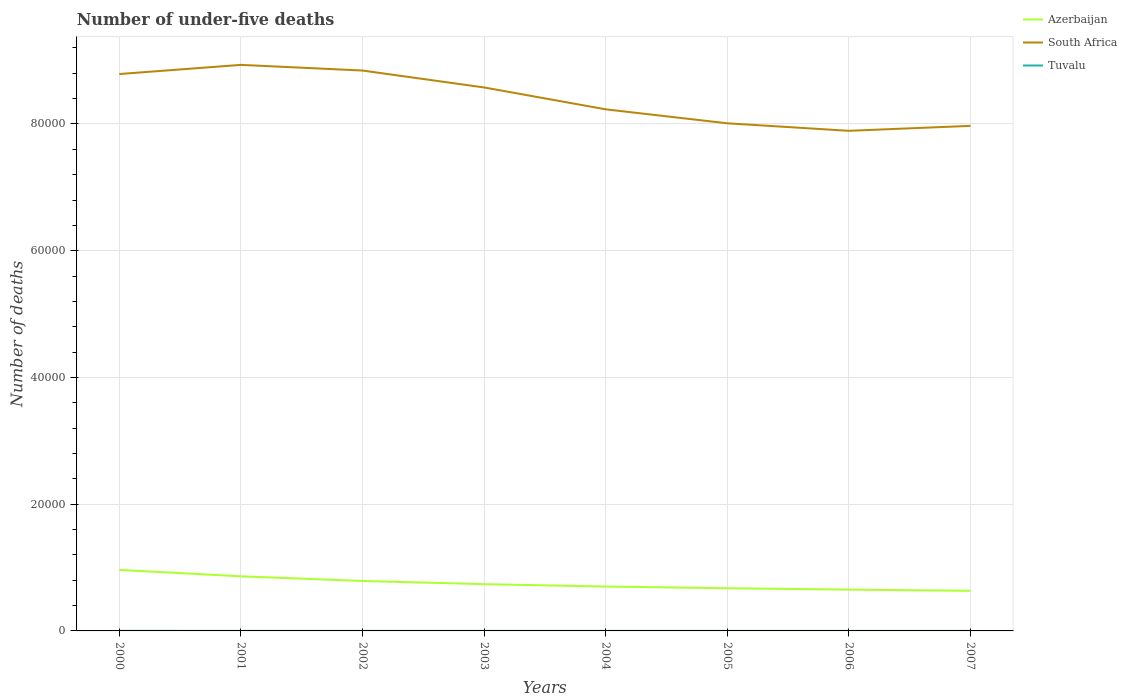How many different coloured lines are there?
Make the answer very short. 3. Across all years, what is the maximum number of under-five deaths in Azerbaijan?
Provide a short and direct response. 6329. What is the total number of under-five deaths in Azerbaijan in the graph?
Ensure brevity in your answer.  1239. What is the difference between the highest and the second highest number of under-five deaths in Azerbaijan?
Your response must be concise. 3301. How many lines are there?
Offer a very short reply. 3. What is the difference between two consecutive major ticks on the Y-axis?
Offer a very short reply. 2.00e+04. Does the graph contain any zero values?
Your response must be concise. No. Does the graph contain grids?
Your answer should be compact. Yes. Where does the legend appear in the graph?
Your answer should be very brief. Top right. How are the legend labels stacked?
Your answer should be very brief. Vertical. What is the title of the graph?
Offer a very short reply. Number of under-five deaths. Does "American Samoa" appear as one of the legend labels in the graph?
Your answer should be very brief. No. What is the label or title of the X-axis?
Provide a succinct answer. Years. What is the label or title of the Y-axis?
Provide a short and direct response. Number of deaths. What is the Number of deaths of Azerbaijan in 2000?
Your response must be concise. 9630. What is the Number of deaths of South Africa in 2000?
Offer a very short reply. 8.79e+04. What is the Number of deaths of Azerbaijan in 2001?
Give a very brief answer. 8618. What is the Number of deaths in South Africa in 2001?
Your answer should be compact. 8.93e+04. What is the Number of deaths in Azerbaijan in 2002?
Make the answer very short. 7883. What is the Number of deaths in South Africa in 2002?
Make the answer very short. 8.84e+04. What is the Number of deaths of Tuvalu in 2002?
Offer a very short reply. 11. What is the Number of deaths in Azerbaijan in 2003?
Ensure brevity in your answer.  7379. What is the Number of deaths of South Africa in 2003?
Ensure brevity in your answer.  8.58e+04. What is the Number of deaths of Tuvalu in 2003?
Provide a succinct answer. 10. What is the Number of deaths in Azerbaijan in 2004?
Your answer should be very brief. 7006. What is the Number of deaths in South Africa in 2004?
Ensure brevity in your answer.  8.23e+04. What is the Number of deaths of Tuvalu in 2004?
Your answer should be very brief. 9. What is the Number of deaths of Azerbaijan in 2005?
Ensure brevity in your answer.  6737. What is the Number of deaths in South Africa in 2005?
Your answer should be compact. 8.01e+04. What is the Number of deaths of Tuvalu in 2005?
Ensure brevity in your answer.  8. What is the Number of deaths in Azerbaijan in 2006?
Offer a terse response. 6519. What is the Number of deaths in South Africa in 2006?
Provide a short and direct response. 7.89e+04. What is the Number of deaths in Tuvalu in 2006?
Ensure brevity in your answer.  8. What is the Number of deaths in Azerbaijan in 2007?
Your answer should be very brief. 6329. What is the Number of deaths of South Africa in 2007?
Provide a succinct answer. 7.97e+04. Across all years, what is the maximum Number of deaths of Azerbaijan?
Provide a short and direct response. 9630. Across all years, what is the maximum Number of deaths in South Africa?
Your response must be concise. 8.93e+04. Across all years, what is the minimum Number of deaths in Azerbaijan?
Provide a succinct answer. 6329. Across all years, what is the minimum Number of deaths of South Africa?
Provide a short and direct response. 7.89e+04. Across all years, what is the minimum Number of deaths of Tuvalu?
Offer a very short reply. 7. What is the total Number of deaths of Azerbaijan in the graph?
Your response must be concise. 6.01e+04. What is the total Number of deaths of South Africa in the graph?
Make the answer very short. 6.72e+05. What is the difference between the Number of deaths in Azerbaijan in 2000 and that in 2001?
Your answer should be compact. 1012. What is the difference between the Number of deaths of South Africa in 2000 and that in 2001?
Provide a short and direct response. -1445. What is the difference between the Number of deaths of Azerbaijan in 2000 and that in 2002?
Provide a succinct answer. 1747. What is the difference between the Number of deaths in South Africa in 2000 and that in 2002?
Your answer should be very brief. -552. What is the difference between the Number of deaths in Tuvalu in 2000 and that in 2002?
Provide a short and direct response. 1. What is the difference between the Number of deaths in Azerbaijan in 2000 and that in 2003?
Offer a terse response. 2251. What is the difference between the Number of deaths of South Africa in 2000 and that in 2003?
Provide a succinct answer. 2119. What is the difference between the Number of deaths in Azerbaijan in 2000 and that in 2004?
Offer a terse response. 2624. What is the difference between the Number of deaths in South Africa in 2000 and that in 2004?
Your response must be concise. 5570. What is the difference between the Number of deaths of Tuvalu in 2000 and that in 2004?
Keep it short and to the point. 3. What is the difference between the Number of deaths in Azerbaijan in 2000 and that in 2005?
Your answer should be compact. 2893. What is the difference between the Number of deaths in South Africa in 2000 and that in 2005?
Your answer should be compact. 7774. What is the difference between the Number of deaths of Azerbaijan in 2000 and that in 2006?
Your answer should be very brief. 3111. What is the difference between the Number of deaths in South Africa in 2000 and that in 2006?
Provide a short and direct response. 8961. What is the difference between the Number of deaths in Azerbaijan in 2000 and that in 2007?
Provide a short and direct response. 3301. What is the difference between the Number of deaths in South Africa in 2000 and that in 2007?
Your answer should be very brief. 8179. What is the difference between the Number of deaths of Tuvalu in 2000 and that in 2007?
Your answer should be very brief. 5. What is the difference between the Number of deaths of Azerbaijan in 2001 and that in 2002?
Ensure brevity in your answer.  735. What is the difference between the Number of deaths in South Africa in 2001 and that in 2002?
Ensure brevity in your answer.  893. What is the difference between the Number of deaths of Tuvalu in 2001 and that in 2002?
Your answer should be very brief. 0. What is the difference between the Number of deaths of Azerbaijan in 2001 and that in 2003?
Keep it short and to the point. 1239. What is the difference between the Number of deaths of South Africa in 2001 and that in 2003?
Your answer should be very brief. 3564. What is the difference between the Number of deaths in Azerbaijan in 2001 and that in 2004?
Provide a short and direct response. 1612. What is the difference between the Number of deaths of South Africa in 2001 and that in 2004?
Your answer should be compact. 7015. What is the difference between the Number of deaths of Azerbaijan in 2001 and that in 2005?
Make the answer very short. 1881. What is the difference between the Number of deaths in South Africa in 2001 and that in 2005?
Your response must be concise. 9219. What is the difference between the Number of deaths of Azerbaijan in 2001 and that in 2006?
Offer a very short reply. 2099. What is the difference between the Number of deaths in South Africa in 2001 and that in 2006?
Give a very brief answer. 1.04e+04. What is the difference between the Number of deaths of Azerbaijan in 2001 and that in 2007?
Keep it short and to the point. 2289. What is the difference between the Number of deaths of South Africa in 2001 and that in 2007?
Offer a terse response. 9624. What is the difference between the Number of deaths of Tuvalu in 2001 and that in 2007?
Keep it short and to the point. 4. What is the difference between the Number of deaths in Azerbaijan in 2002 and that in 2003?
Your response must be concise. 504. What is the difference between the Number of deaths of South Africa in 2002 and that in 2003?
Offer a very short reply. 2671. What is the difference between the Number of deaths of Tuvalu in 2002 and that in 2003?
Keep it short and to the point. 1. What is the difference between the Number of deaths of Azerbaijan in 2002 and that in 2004?
Provide a succinct answer. 877. What is the difference between the Number of deaths in South Africa in 2002 and that in 2004?
Your response must be concise. 6122. What is the difference between the Number of deaths of Tuvalu in 2002 and that in 2004?
Your response must be concise. 2. What is the difference between the Number of deaths in Azerbaijan in 2002 and that in 2005?
Offer a very short reply. 1146. What is the difference between the Number of deaths of South Africa in 2002 and that in 2005?
Your answer should be very brief. 8326. What is the difference between the Number of deaths of Tuvalu in 2002 and that in 2005?
Give a very brief answer. 3. What is the difference between the Number of deaths in Azerbaijan in 2002 and that in 2006?
Your answer should be compact. 1364. What is the difference between the Number of deaths of South Africa in 2002 and that in 2006?
Give a very brief answer. 9513. What is the difference between the Number of deaths in Azerbaijan in 2002 and that in 2007?
Make the answer very short. 1554. What is the difference between the Number of deaths in South Africa in 2002 and that in 2007?
Make the answer very short. 8731. What is the difference between the Number of deaths in Tuvalu in 2002 and that in 2007?
Offer a very short reply. 4. What is the difference between the Number of deaths of Azerbaijan in 2003 and that in 2004?
Offer a very short reply. 373. What is the difference between the Number of deaths in South Africa in 2003 and that in 2004?
Provide a short and direct response. 3451. What is the difference between the Number of deaths of Azerbaijan in 2003 and that in 2005?
Give a very brief answer. 642. What is the difference between the Number of deaths of South Africa in 2003 and that in 2005?
Provide a short and direct response. 5655. What is the difference between the Number of deaths of Tuvalu in 2003 and that in 2005?
Give a very brief answer. 2. What is the difference between the Number of deaths of Azerbaijan in 2003 and that in 2006?
Provide a short and direct response. 860. What is the difference between the Number of deaths of South Africa in 2003 and that in 2006?
Provide a succinct answer. 6842. What is the difference between the Number of deaths of Azerbaijan in 2003 and that in 2007?
Your answer should be very brief. 1050. What is the difference between the Number of deaths in South Africa in 2003 and that in 2007?
Your response must be concise. 6060. What is the difference between the Number of deaths of Tuvalu in 2003 and that in 2007?
Make the answer very short. 3. What is the difference between the Number of deaths of Azerbaijan in 2004 and that in 2005?
Provide a short and direct response. 269. What is the difference between the Number of deaths in South Africa in 2004 and that in 2005?
Offer a very short reply. 2204. What is the difference between the Number of deaths in Tuvalu in 2004 and that in 2005?
Provide a succinct answer. 1. What is the difference between the Number of deaths in Azerbaijan in 2004 and that in 2006?
Your response must be concise. 487. What is the difference between the Number of deaths of South Africa in 2004 and that in 2006?
Your answer should be compact. 3391. What is the difference between the Number of deaths of Tuvalu in 2004 and that in 2006?
Provide a short and direct response. 1. What is the difference between the Number of deaths of Azerbaijan in 2004 and that in 2007?
Your answer should be compact. 677. What is the difference between the Number of deaths of South Africa in 2004 and that in 2007?
Your answer should be very brief. 2609. What is the difference between the Number of deaths of Azerbaijan in 2005 and that in 2006?
Offer a terse response. 218. What is the difference between the Number of deaths in South Africa in 2005 and that in 2006?
Offer a very short reply. 1187. What is the difference between the Number of deaths in Azerbaijan in 2005 and that in 2007?
Provide a succinct answer. 408. What is the difference between the Number of deaths of South Africa in 2005 and that in 2007?
Offer a very short reply. 405. What is the difference between the Number of deaths in Tuvalu in 2005 and that in 2007?
Your answer should be compact. 1. What is the difference between the Number of deaths in Azerbaijan in 2006 and that in 2007?
Your answer should be very brief. 190. What is the difference between the Number of deaths of South Africa in 2006 and that in 2007?
Your answer should be very brief. -782. What is the difference between the Number of deaths of Azerbaijan in 2000 and the Number of deaths of South Africa in 2001?
Offer a terse response. -7.97e+04. What is the difference between the Number of deaths of Azerbaijan in 2000 and the Number of deaths of Tuvalu in 2001?
Your response must be concise. 9619. What is the difference between the Number of deaths in South Africa in 2000 and the Number of deaths in Tuvalu in 2001?
Your answer should be very brief. 8.79e+04. What is the difference between the Number of deaths in Azerbaijan in 2000 and the Number of deaths in South Africa in 2002?
Your response must be concise. -7.88e+04. What is the difference between the Number of deaths in Azerbaijan in 2000 and the Number of deaths in Tuvalu in 2002?
Offer a terse response. 9619. What is the difference between the Number of deaths of South Africa in 2000 and the Number of deaths of Tuvalu in 2002?
Your answer should be very brief. 8.79e+04. What is the difference between the Number of deaths of Azerbaijan in 2000 and the Number of deaths of South Africa in 2003?
Your response must be concise. -7.61e+04. What is the difference between the Number of deaths in Azerbaijan in 2000 and the Number of deaths in Tuvalu in 2003?
Your response must be concise. 9620. What is the difference between the Number of deaths in South Africa in 2000 and the Number of deaths in Tuvalu in 2003?
Offer a terse response. 8.79e+04. What is the difference between the Number of deaths of Azerbaijan in 2000 and the Number of deaths of South Africa in 2004?
Make the answer very short. -7.27e+04. What is the difference between the Number of deaths of Azerbaijan in 2000 and the Number of deaths of Tuvalu in 2004?
Give a very brief answer. 9621. What is the difference between the Number of deaths in South Africa in 2000 and the Number of deaths in Tuvalu in 2004?
Your answer should be compact. 8.79e+04. What is the difference between the Number of deaths of Azerbaijan in 2000 and the Number of deaths of South Africa in 2005?
Ensure brevity in your answer.  -7.05e+04. What is the difference between the Number of deaths of Azerbaijan in 2000 and the Number of deaths of Tuvalu in 2005?
Your answer should be very brief. 9622. What is the difference between the Number of deaths of South Africa in 2000 and the Number of deaths of Tuvalu in 2005?
Ensure brevity in your answer.  8.79e+04. What is the difference between the Number of deaths in Azerbaijan in 2000 and the Number of deaths in South Africa in 2006?
Provide a short and direct response. -6.93e+04. What is the difference between the Number of deaths in Azerbaijan in 2000 and the Number of deaths in Tuvalu in 2006?
Your response must be concise. 9622. What is the difference between the Number of deaths of South Africa in 2000 and the Number of deaths of Tuvalu in 2006?
Your answer should be compact. 8.79e+04. What is the difference between the Number of deaths of Azerbaijan in 2000 and the Number of deaths of South Africa in 2007?
Your answer should be very brief. -7.01e+04. What is the difference between the Number of deaths in Azerbaijan in 2000 and the Number of deaths in Tuvalu in 2007?
Your answer should be very brief. 9623. What is the difference between the Number of deaths of South Africa in 2000 and the Number of deaths of Tuvalu in 2007?
Ensure brevity in your answer.  8.79e+04. What is the difference between the Number of deaths of Azerbaijan in 2001 and the Number of deaths of South Africa in 2002?
Keep it short and to the point. -7.98e+04. What is the difference between the Number of deaths of Azerbaijan in 2001 and the Number of deaths of Tuvalu in 2002?
Make the answer very short. 8607. What is the difference between the Number of deaths of South Africa in 2001 and the Number of deaths of Tuvalu in 2002?
Make the answer very short. 8.93e+04. What is the difference between the Number of deaths of Azerbaijan in 2001 and the Number of deaths of South Africa in 2003?
Make the answer very short. -7.71e+04. What is the difference between the Number of deaths in Azerbaijan in 2001 and the Number of deaths in Tuvalu in 2003?
Provide a succinct answer. 8608. What is the difference between the Number of deaths of South Africa in 2001 and the Number of deaths of Tuvalu in 2003?
Offer a very short reply. 8.93e+04. What is the difference between the Number of deaths in Azerbaijan in 2001 and the Number of deaths in South Africa in 2004?
Ensure brevity in your answer.  -7.37e+04. What is the difference between the Number of deaths in Azerbaijan in 2001 and the Number of deaths in Tuvalu in 2004?
Your response must be concise. 8609. What is the difference between the Number of deaths in South Africa in 2001 and the Number of deaths in Tuvalu in 2004?
Offer a very short reply. 8.93e+04. What is the difference between the Number of deaths of Azerbaijan in 2001 and the Number of deaths of South Africa in 2005?
Your response must be concise. -7.15e+04. What is the difference between the Number of deaths of Azerbaijan in 2001 and the Number of deaths of Tuvalu in 2005?
Keep it short and to the point. 8610. What is the difference between the Number of deaths of South Africa in 2001 and the Number of deaths of Tuvalu in 2005?
Offer a terse response. 8.93e+04. What is the difference between the Number of deaths in Azerbaijan in 2001 and the Number of deaths in South Africa in 2006?
Keep it short and to the point. -7.03e+04. What is the difference between the Number of deaths in Azerbaijan in 2001 and the Number of deaths in Tuvalu in 2006?
Provide a short and direct response. 8610. What is the difference between the Number of deaths in South Africa in 2001 and the Number of deaths in Tuvalu in 2006?
Your answer should be very brief. 8.93e+04. What is the difference between the Number of deaths of Azerbaijan in 2001 and the Number of deaths of South Africa in 2007?
Ensure brevity in your answer.  -7.11e+04. What is the difference between the Number of deaths in Azerbaijan in 2001 and the Number of deaths in Tuvalu in 2007?
Your answer should be compact. 8611. What is the difference between the Number of deaths of South Africa in 2001 and the Number of deaths of Tuvalu in 2007?
Your answer should be compact. 8.93e+04. What is the difference between the Number of deaths in Azerbaijan in 2002 and the Number of deaths in South Africa in 2003?
Make the answer very short. -7.79e+04. What is the difference between the Number of deaths of Azerbaijan in 2002 and the Number of deaths of Tuvalu in 2003?
Offer a very short reply. 7873. What is the difference between the Number of deaths of South Africa in 2002 and the Number of deaths of Tuvalu in 2003?
Keep it short and to the point. 8.84e+04. What is the difference between the Number of deaths in Azerbaijan in 2002 and the Number of deaths in South Africa in 2004?
Offer a terse response. -7.44e+04. What is the difference between the Number of deaths of Azerbaijan in 2002 and the Number of deaths of Tuvalu in 2004?
Your answer should be compact. 7874. What is the difference between the Number of deaths of South Africa in 2002 and the Number of deaths of Tuvalu in 2004?
Your answer should be compact. 8.84e+04. What is the difference between the Number of deaths in Azerbaijan in 2002 and the Number of deaths in South Africa in 2005?
Provide a succinct answer. -7.22e+04. What is the difference between the Number of deaths of Azerbaijan in 2002 and the Number of deaths of Tuvalu in 2005?
Give a very brief answer. 7875. What is the difference between the Number of deaths in South Africa in 2002 and the Number of deaths in Tuvalu in 2005?
Offer a very short reply. 8.84e+04. What is the difference between the Number of deaths of Azerbaijan in 2002 and the Number of deaths of South Africa in 2006?
Offer a terse response. -7.10e+04. What is the difference between the Number of deaths in Azerbaijan in 2002 and the Number of deaths in Tuvalu in 2006?
Your answer should be very brief. 7875. What is the difference between the Number of deaths of South Africa in 2002 and the Number of deaths of Tuvalu in 2006?
Your response must be concise. 8.84e+04. What is the difference between the Number of deaths in Azerbaijan in 2002 and the Number of deaths in South Africa in 2007?
Your answer should be very brief. -7.18e+04. What is the difference between the Number of deaths of Azerbaijan in 2002 and the Number of deaths of Tuvalu in 2007?
Your answer should be compact. 7876. What is the difference between the Number of deaths of South Africa in 2002 and the Number of deaths of Tuvalu in 2007?
Give a very brief answer. 8.84e+04. What is the difference between the Number of deaths of Azerbaijan in 2003 and the Number of deaths of South Africa in 2004?
Ensure brevity in your answer.  -7.49e+04. What is the difference between the Number of deaths of Azerbaijan in 2003 and the Number of deaths of Tuvalu in 2004?
Your response must be concise. 7370. What is the difference between the Number of deaths in South Africa in 2003 and the Number of deaths in Tuvalu in 2004?
Provide a succinct answer. 8.58e+04. What is the difference between the Number of deaths of Azerbaijan in 2003 and the Number of deaths of South Africa in 2005?
Provide a short and direct response. -7.27e+04. What is the difference between the Number of deaths in Azerbaijan in 2003 and the Number of deaths in Tuvalu in 2005?
Your answer should be compact. 7371. What is the difference between the Number of deaths of South Africa in 2003 and the Number of deaths of Tuvalu in 2005?
Give a very brief answer. 8.58e+04. What is the difference between the Number of deaths in Azerbaijan in 2003 and the Number of deaths in South Africa in 2006?
Give a very brief answer. -7.15e+04. What is the difference between the Number of deaths in Azerbaijan in 2003 and the Number of deaths in Tuvalu in 2006?
Ensure brevity in your answer.  7371. What is the difference between the Number of deaths of South Africa in 2003 and the Number of deaths of Tuvalu in 2006?
Offer a very short reply. 8.58e+04. What is the difference between the Number of deaths of Azerbaijan in 2003 and the Number of deaths of South Africa in 2007?
Offer a very short reply. -7.23e+04. What is the difference between the Number of deaths of Azerbaijan in 2003 and the Number of deaths of Tuvalu in 2007?
Your answer should be very brief. 7372. What is the difference between the Number of deaths of South Africa in 2003 and the Number of deaths of Tuvalu in 2007?
Your answer should be very brief. 8.58e+04. What is the difference between the Number of deaths of Azerbaijan in 2004 and the Number of deaths of South Africa in 2005?
Make the answer very short. -7.31e+04. What is the difference between the Number of deaths in Azerbaijan in 2004 and the Number of deaths in Tuvalu in 2005?
Your answer should be very brief. 6998. What is the difference between the Number of deaths in South Africa in 2004 and the Number of deaths in Tuvalu in 2005?
Provide a succinct answer. 8.23e+04. What is the difference between the Number of deaths of Azerbaijan in 2004 and the Number of deaths of South Africa in 2006?
Provide a succinct answer. -7.19e+04. What is the difference between the Number of deaths of Azerbaijan in 2004 and the Number of deaths of Tuvalu in 2006?
Give a very brief answer. 6998. What is the difference between the Number of deaths in South Africa in 2004 and the Number of deaths in Tuvalu in 2006?
Ensure brevity in your answer.  8.23e+04. What is the difference between the Number of deaths in Azerbaijan in 2004 and the Number of deaths in South Africa in 2007?
Provide a succinct answer. -7.27e+04. What is the difference between the Number of deaths in Azerbaijan in 2004 and the Number of deaths in Tuvalu in 2007?
Keep it short and to the point. 6999. What is the difference between the Number of deaths of South Africa in 2004 and the Number of deaths of Tuvalu in 2007?
Give a very brief answer. 8.23e+04. What is the difference between the Number of deaths in Azerbaijan in 2005 and the Number of deaths in South Africa in 2006?
Offer a terse response. -7.22e+04. What is the difference between the Number of deaths in Azerbaijan in 2005 and the Number of deaths in Tuvalu in 2006?
Your answer should be compact. 6729. What is the difference between the Number of deaths of South Africa in 2005 and the Number of deaths of Tuvalu in 2006?
Offer a very short reply. 8.01e+04. What is the difference between the Number of deaths in Azerbaijan in 2005 and the Number of deaths in South Africa in 2007?
Your answer should be compact. -7.30e+04. What is the difference between the Number of deaths of Azerbaijan in 2005 and the Number of deaths of Tuvalu in 2007?
Provide a succinct answer. 6730. What is the difference between the Number of deaths in South Africa in 2005 and the Number of deaths in Tuvalu in 2007?
Keep it short and to the point. 8.01e+04. What is the difference between the Number of deaths of Azerbaijan in 2006 and the Number of deaths of South Africa in 2007?
Make the answer very short. -7.32e+04. What is the difference between the Number of deaths of Azerbaijan in 2006 and the Number of deaths of Tuvalu in 2007?
Your answer should be very brief. 6512. What is the difference between the Number of deaths of South Africa in 2006 and the Number of deaths of Tuvalu in 2007?
Offer a terse response. 7.89e+04. What is the average Number of deaths of Azerbaijan per year?
Provide a succinct answer. 7512.62. What is the average Number of deaths of South Africa per year?
Offer a terse response. 8.41e+04. What is the average Number of deaths of Tuvalu per year?
Keep it short and to the point. 9.5. In the year 2000, what is the difference between the Number of deaths of Azerbaijan and Number of deaths of South Africa?
Make the answer very short. -7.82e+04. In the year 2000, what is the difference between the Number of deaths of Azerbaijan and Number of deaths of Tuvalu?
Ensure brevity in your answer.  9618. In the year 2000, what is the difference between the Number of deaths of South Africa and Number of deaths of Tuvalu?
Give a very brief answer. 8.79e+04. In the year 2001, what is the difference between the Number of deaths of Azerbaijan and Number of deaths of South Africa?
Your answer should be compact. -8.07e+04. In the year 2001, what is the difference between the Number of deaths in Azerbaijan and Number of deaths in Tuvalu?
Offer a terse response. 8607. In the year 2001, what is the difference between the Number of deaths in South Africa and Number of deaths in Tuvalu?
Make the answer very short. 8.93e+04. In the year 2002, what is the difference between the Number of deaths of Azerbaijan and Number of deaths of South Africa?
Offer a very short reply. -8.05e+04. In the year 2002, what is the difference between the Number of deaths of Azerbaijan and Number of deaths of Tuvalu?
Your answer should be compact. 7872. In the year 2002, what is the difference between the Number of deaths of South Africa and Number of deaths of Tuvalu?
Your answer should be very brief. 8.84e+04. In the year 2003, what is the difference between the Number of deaths of Azerbaijan and Number of deaths of South Africa?
Offer a very short reply. -7.84e+04. In the year 2003, what is the difference between the Number of deaths in Azerbaijan and Number of deaths in Tuvalu?
Your answer should be compact. 7369. In the year 2003, what is the difference between the Number of deaths of South Africa and Number of deaths of Tuvalu?
Your response must be concise. 8.57e+04. In the year 2004, what is the difference between the Number of deaths of Azerbaijan and Number of deaths of South Africa?
Provide a short and direct response. -7.53e+04. In the year 2004, what is the difference between the Number of deaths of Azerbaijan and Number of deaths of Tuvalu?
Your answer should be compact. 6997. In the year 2004, what is the difference between the Number of deaths in South Africa and Number of deaths in Tuvalu?
Offer a terse response. 8.23e+04. In the year 2005, what is the difference between the Number of deaths of Azerbaijan and Number of deaths of South Africa?
Your answer should be compact. -7.34e+04. In the year 2005, what is the difference between the Number of deaths in Azerbaijan and Number of deaths in Tuvalu?
Make the answer very short. 6729. In the year 2005, what is the difference between the Number of deaths in South Africa and Number of deaths in Tuvalu?
Your answer should be very brief. 8.01e+04. In the year 2006, what is the difference between the Number of deaths of Azerbaijan and Number of deaths of South Africa?
Your answer should be very brief. -7.24e+04. In the year 2006, what is the difference between the Number of deaths in Azerbaijan and Number of deaths in Tuvalu?
Give a very brief answer. 6511. In the year 2006, what is the difference between the Number of deaths of South Africa and Number of deaths of Tuvalu?
Offer a very short reply. 7.89e+04. In the year 2007, what is the difference between the Number of deaths of Azerbaijan and Number of deaths of South Africa?
Provide a short and direct response. -7.34e+04. In the year 2007, what is the difference between the Number of deaths in Azerbaijan and Number of deaths in Tuvalu?
Give a very brief answer. 6322. In the year 2007, what is the difference between the Number of deaths in South Africa and Number of deaths in Tuvalu?
Your response must be concise. 7.97e+04. What is the ratio of the Number of deaths in Azerbaijan in 2000 to that in 2001?
Your answer should be very brief. 1.12. What is the ratio of the Number of deaths in South Africa in 2000 to that in 2001?
Offer a terse response. 0.98. What is the ratio of the Number of deaths in Azerbaijan in 2000 to that in 2002?
Make the answer very short. 1.22. What is the ratio of the Number of deaths of South Africa in 2000 to that in 2002?
Give a very brief answer. 0.99. What is the ratio of the Number of deaths of Tuvalu in 2000 to that in 2002?
Provide a short and direct response. 1.09. What is the ratio of the Number of deaths in Azerbaijan in 2000 to that in 2003?
Your answer should be very brief. 1.31. What is the ratio of the Number of deaths in South Africa in 2000 to that in 2003?
Your answer should be compact. 1.02. What is the ratio of the Number of deaths in Tuvalu in 2000 to that in 2003?
Keep it short and to the point. 1.2. What is the ratio of the Number of deaths of Azerbaijan in 2000 to that in 2004?
Your response must be concise. 1.37. What is the ratio of the Number of deaths of South Africa in 2000 to that in 2004?
Offer a very short reply. 1.07. What is the ratio of the Number of deaths of Tuvalu in 2000 to that in 2004?
Your answer should be very brief. 1.33. What is the ratio of the Number of deaths of Azerbaijan in 2000 to that in 2005?
Keep it short and to the point. 1.43. What is the ratio of the Number of deaths of South Africa in 2000 to that in 2005?
Keep it short and to the point. 1.1. What is the ratio of the Number of deaths of Azerbaijan in 2000 to that in 2006?
Your answer should be very brief. 1.48. What is the ratio of the Number of deaths in South Africa in 2000 to that in 2006?
Offer a very short reply. 1.11. What is the ratio of the Number of deaths in Azerbaijan in 2000 to that in 2007?
Your response must be concise. 1.52. What is the ratio of the Number of deaths in South Africa in 2000 to that in 2007?
Offer a terse response. 1.1. What is the ratio of the Number of deaths of Tuvalu in 2000 to that in 2007?
Offer a very short reply. 1.71. What is the ratio of the Number of deaths of Azerbaijan in 2001 to that in 2002?
Provide a short and direct response. 1.09. What is the ratio of the Number of deaths of Azerbaijan in 2001 to that in 2003?
Keep it short and to the point. 1.17. What is the ratio of the Number of deaths of South Africa in 2001 to that in 2003?
Give a very brief answer. 1.04. What is the ratio of the Number of deaths in Azerbaijan in 2001 to that in 2004?
Ensure brevity in your answer.  1.23. What is the ratio of the Number of deaths in South Africa in 2001 to that in 2004?
Offer a very short reply. 1.09. What is the ratio of the Number of deaths of Tuvalu in 2001 to that in 2004?
Offer a terse response. 1.22. What is the ratio of the Number of deaths in Azerbaijan in 2001 to that in 2005?
Your response must be concise. 1.28. What is the ratio of the Number of deaths of South Africa in 2001 to that in 2005?
Offer a very short reply. 1.12. What is the ratio of the Number of deaths in Tuvalu in 2001 to that in 2005?
Offer a terse response. 1.38. What is the ratio of the Number of deaths of Azerbaijan in 2001 to that in 2006?
Your answer should be very brief. 1.32. What is the ratio of the Number of deaths in South Africa in 2001 to that in 2006?
Your answer should be very brief. 1.13. What is the ratio of the Number of deaths of Tuvalu in 2001 to that in 2006?
Your answer should be compact. 1.38. What is the ratio of the Number of deaths in Azerbaijan in 2001 to that in 2007?
Your response must be concise. 1.36. What is the ratio of the Number of deaths in South Africa in 2001 to that in 2007?
Ensure brevity in your answer.  1.12. What is the ratio of the Number of deaths in Tuvalu in 2001 to that in 2007?
Offer a terse response. 1.57. What is the ratio of the Number of deaths of Azerbaijan in 2002 to that in 2003?
Ensure brevity in your answer.  1.07. What is the ratio of the Number of deaths of South Africa in 2002 to that in 2003?
Offer a terse response. 1.03. What is the ratio of the Number of deaths of Tuvalu in 2002 to that in 2003?
Your answer should be compact. 1.1. What is the ratio of the Number of deaths of Azerbaijan in 2002 to that in 2004?
Offer a very short reply. 1.13. What is the ratio of the Number of deaths of South Africa in 2002 to that in 2004?
Offer a terse response. 1.07. What is the ratio of the Number of deaths in Tuvalu in 2002 to that in 2004?
Offer a very short reply. 1.22. What is the ratio of the Number of deaths of Azerbaijan in 2002 to that in 2005?
Your answer should be compact. 1.17. What is the ratio of the Number of deaths in South Africa in 2002 to that in 2005?
Provide a short and direct response. 1.1. What is the ratio of the Number of deaths of Tuvalu in 2002 to that in 2005?
Your answer should be very brief. 1.38. What is the ratio of the Number of deaths of Azerbaijan in 2002 to that in 2006?
Keep it short and to the point. 1.21. What is the ratio of the Number of deaths of South Africa in 2002 to that in 2006?
Your response must be concise. 1.12. What is the ratio of the Number of deaths of Tuvalu in 2002 to that in 2006?
Provide a succinct answer. 1.38. What is the ratio of the Number of deaths of Azerbaijan in 2002 to that in 2007?
Provide a succinct answer. 1.25. What is the ratio of the Number of deaths of South Africa in 2002 to that in 2007?
Your answer should be very brief. 1.11. What is the ratio of the Number of deaths of Tuvalu in 2002 to that in 2007?
Ensure brevity in your answer.  1.57. What is the ratio of the Number of deaths in Azerbaijan in 2003 to that in 2004?
Offer a very short reply. 1.05. What is the ratio of the Number of deaths in South Africa in 2003 to that in 2004?
Ensure brevity in your answer.  1.04. What is the ratio of the Number of deaths of Tuvalu in 2003 to that in 2004?
Ensure brevity in your answer.  1.11. What is the ratio of the Number of deaths of Azerbaijan in 2003 to that in 2005?
Provide a short and direct response. 1.1. What is the ratio of the Number of deaths in South Africa in 2003 to that in 2005?
Give a very brief answer. 1.07. What is the ratio of the Number of deaths of Tuvalu in 2003 to that in 2005?
Offer a terse response. 1.25. What is the ratio of the Number of deaths in Azerbaijan in 2003 to that in 2006?
Provide a short and direct response. 1.13. What is the ratio of the Number of deaths in South Africa in 2003 to that in 2006?
Provide a short and direct response. 1.09. What is the ratio of the Number of deaths of Azerbaijan in 2003 to that in 2007?
Make the answer very short. 1.17. What is the ratio of the Number of deaths in South Africa in 2003 to that in 2007?
Your response must be concise. 1.08. What is the ratio of the Number of deaths of Tuvalu in 2003 to that in 2007?
Your answer should be very brief. 1.43. What is the ratio of the Number of deaths in Azerbaijan in 2004 to that in 2005?
Your answer should be very brief. 1.04. What is the ratio of the Number of deaths of South Africa in 2004 to that in 2005?
Keep it short and to the point. 1.03. What is the ratio of the Number of deaths of Azerbaijan in 2004 to that in 2006?
Your response must be concise. 1.07. What is the ratio of the Number of deaths of South Africa in 2004 to that in 2006?
Make the answer very short. 1.04. What is the ratio of the Number of deaths in Azerbaijan in 2004 to that in 2007?
Your answer should be very brief. 1.11. What is the ratio of the Number of deaths of South Africa in 2004 to that in 2007?
Provide a succinct answer. 1.03. What is the ratio of the Number of deaths of Azerbaijan in 2005 to that in 2006?
Keep it short and to the point. 1.03. What is the ratio of the Number of deaths of South Africa in 2005 to that in 2006?
Your answer should be compact. 1.01. What is the ratio of the Number of deaths of Tuvalu in 2005 to that in 2006?
Keep it short and to the point. 1. What is the ratio of the Number of deaths of Azerbaijan in 2005 to that in 2007?
Ensure brevity in your answer.  1.06. What is the ratio of the Number of deaths in South Africa in 2005 to that in 2007?
Give a very brief answer. 1.01. What is the ratio of the Number of deaths of Azerbaijan in 2006 to that in 2007?
Ensure brevity in your answer.  1.03. What is the ratio of the Number of deaths in South Africa in 2006 to that in 2007?
Offer a very short reply. 0.99. What is the ratio of the Number of deaths in Tuvalu in 2006 to that in 2007?
Offer a terse response. 1.14. What is the difference between the highest and the second highest Number of deaths in Azerbaijan?
Offer a very short reply. 1012. What is the difference between the highest and the second highest Number of deaths of South Africa?
Your response must be concise. 893. What is the difference between the highest and the lowest Number of deaths in Azerbaijan?
Offer a very short reply. 3301. What is the difference between the highest and the lowest Number of deaths of South Africa?
Provide a short and direct response. 1.04e+04. 